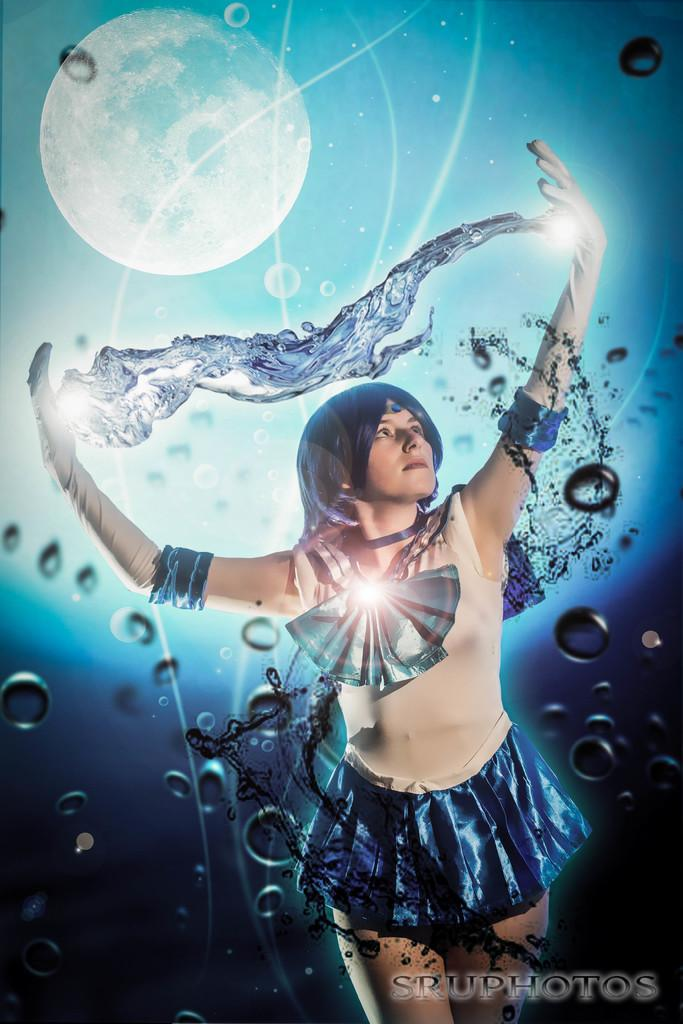What is the main subject of the image? There is a person wearing clothes in the image. What celestial object can be seen in the top left of the image? There is a moon in the top left of the image. What is present in the bottom right of the image? There is a watermark in the bottom right of the image. What type of rail can be seen in the image? There is no rail present in the image. 